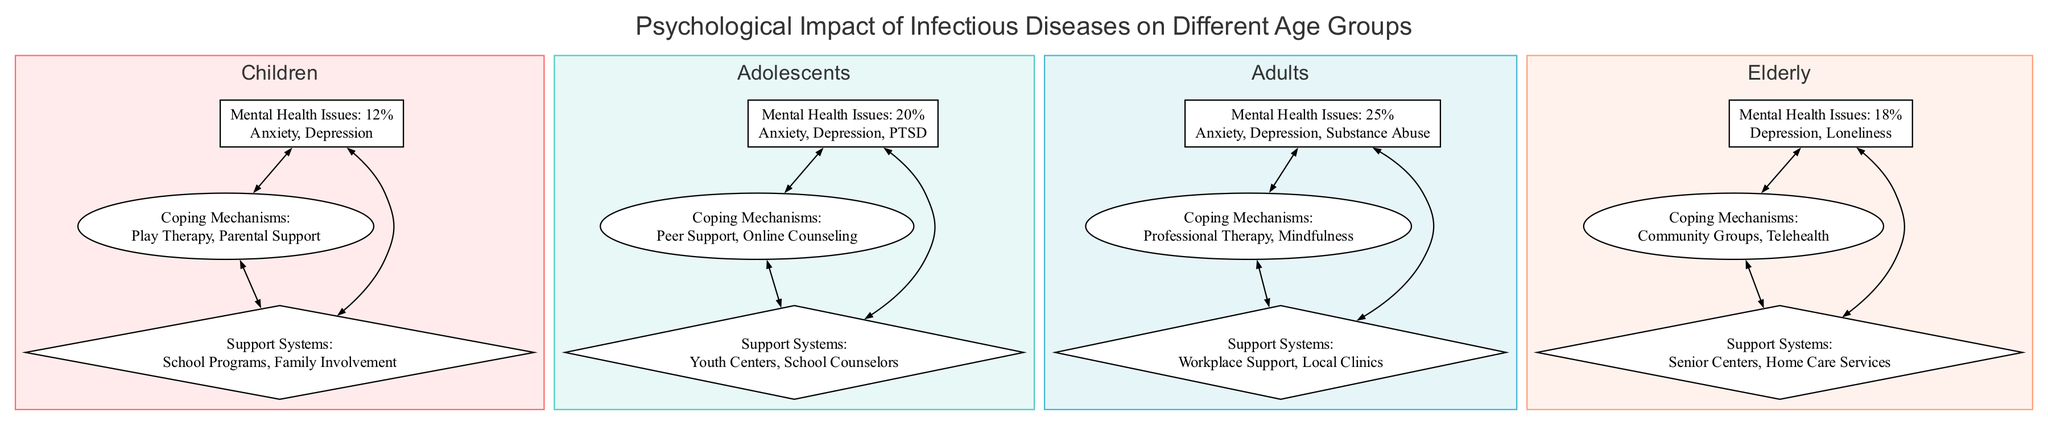What is the mental health issue percentage for Adolescents? The diagram specifies the mental health statistics for each age group. For Adolescents, the data indicates a percentage of 20% for mental health issues.
Answer: 20% Which coping mechanism is listed for Adults? In the section for coping mechanisms under the Adults category, the diagram states that "Professional Therapy" is one of the mechanisms listed.
Answer: Professional Therapy What support systems are available for the Elderly? The support systems node for the Elderly highlights "Senior Centers" and "Home Care Services" as the support options available.
Answer: Senior Centers, Home Care Services Which age group has the highest percentage of mental health issues? By comparing the percentages across all age groups, Adults have the highest percentage at 25%.
Answer: 25% What are the coping mechanisms for Children? The coping mechanisms listed specifically for Children include "Play Therapy" and "Parental Support", indicating their focus on support from family and play-based activities.
Answer: Play Therapy, Parental Support How do coping mechanisms relate to support systems across age groups? Each age group has a direct connection between coping mechanisms and support systems in the diagram. For example, after coping mechanisms for Adolescents, it leads to peer support and online counseling followed by linking to available support like youth centers and school counselors.
Answer: Direct connection What percentage of the Elderly experience depression? In the mental health statistics for the Elderly, "Depression" is one of the issues noted, but it doesn't specify an exact percentage for just depression; instead, it provides the overall percentage of 18% which encompasses all mental health issues listed.
Answer: 18% What age group is most likely to experience Substance Abuse? The diagram shows that under Adults, Substance Abuse is explicitly listed among their mental health issues, suggesting this age group is most affected by it.
Answer: Adults What are the main issues faced by Children according to the diagram? For Children, the mental health statistics indicate that they primarily face "Anxiety" and "Depression".
Answer: Anxiety, Depression 